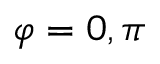<formula> <loc_0><loc_0><loc_500><loc_500>\varphi = 0 , \pi</formula> 